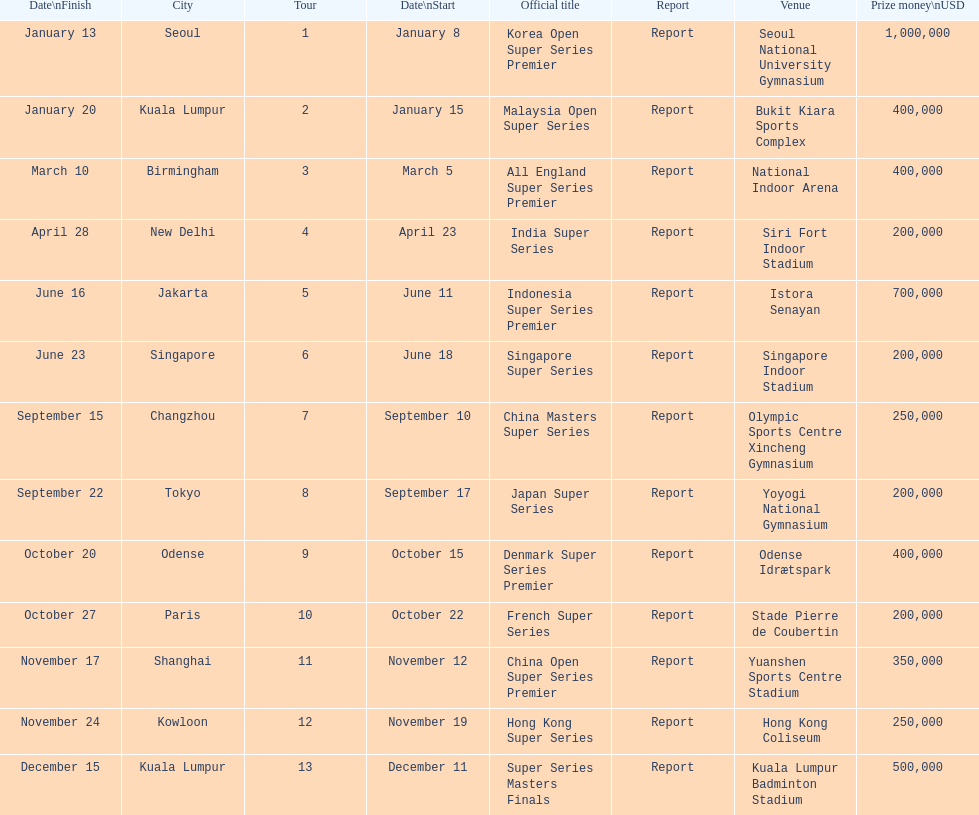Can you parse all the data within this table? {'header': ['Date\\nFinish', 'City', 'Tour', 'Date\\nStart', 'Official title', 'Report', 'Venue', 'Prize money\\nUSD'], 'rows': [['January 13', 'Seoul', '1', 'January 8', 'Korea Open Super Series Premier', 'Report', 'Seoul National University Gymnasium', '1,000,000'], ['January 20', 'Kuala Lumpur', '2', 'January 15', 'Malaysia Open Super Series', 'Report', 'Bukit Kiara Sports Complex', '400,000'], ['March 10', 'Birmingham', '3', 'March 5', 'All England Super Series Premier', 'Report', 'National Indoor Arena', '400,000'], ['April 28', 'New Delhi', '4', 'April 23', 'India Super Series', 'Report', 'Siri Fort Indoor Stadium', '200,000'], ['June 16', 'Jakarta', '5', 'June 11', 'Indonesia Super Series Premier', 'Report', 'Istora Senayan', '700,000'], ['June 23', 'Singapore', '6', 'June 18', 'Singapore Super Series', 'Report', 'Singapore Indoor Stadium', '200,000'], ['September 15', 'Changzhou', '7', 'September 10', 'China Masters Super Series', 'Report', 'Olympic Sports Centre Xincheng Gymnasium', '250,000'], ['September 22', 'Tokyo', '8', 'September 17', 'Japan Super Series', 'Report', 'Yoyogi National Gymnasium', '200,000'], ['October 20', 'Odense', '9', 'October 15', 'Denmark Super Series Premier', 'Report', 'Odense Idrætspark', '400,000'], ['October 27', 'Paris', '10', 'October 22', 'French Super Series', 'Report', 'Stade Pierre de Coubertin', '200,000'], ['November 17', 'Shanghai', '11', 'November 12', 'China Open Super Series Premier', 'Report', 'Yuanshen Sports Centre Stadium', '350,000'], ['November 24', 'Kowloon', '12', 'November 19', 'Hong Kong Super Series', 'Report', 'Hong Kong Coliseum', '250,000'], ['December 15', 'Kuala Lumpur', '13', 'December 11', 'Super Series Masters Finals', 'Report', 'Kuala Lumpur Badminton Stadium', '500,000']]} Which tour was the only one to take place in december? Super Series Masters Finals. 